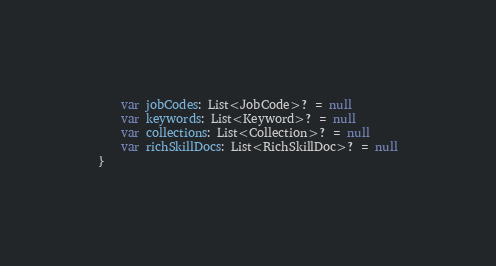<code> <loc_0><loc_0><loc_500><loc_500><_Kotlin_>    var jobCodes: List<JobCode>? = null
    var keywords: List<Keyword>? = null
    var collections: List<Collection>? = null
    var richSkillDocs: List<RichSkillDoc>? = null
}</code> 